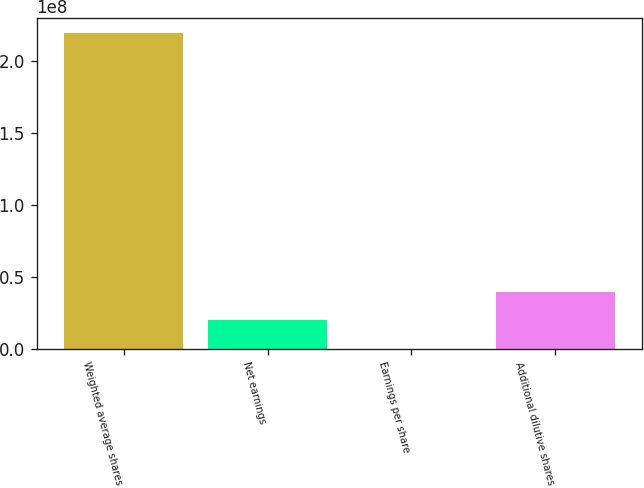<chart> <loc_0><loc_0><loc_500><loc_500><bar_chart><fcel>Weighted average shares<fcel>Net earnings<fcel>Earnings per share<fcel>Additional dilutive shares<nl><fcel>2.19403e+08<fcel>1.99457e+07<fcel>0.94<fcel>3.98915e+07<nl></chart> 